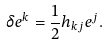<formula> <loc_0><loc_0><loc_500><loc_500>\delta e ^ { k } = \frac { 1 } { 2 } h _ { k j } e ^ { j } .</formula> 